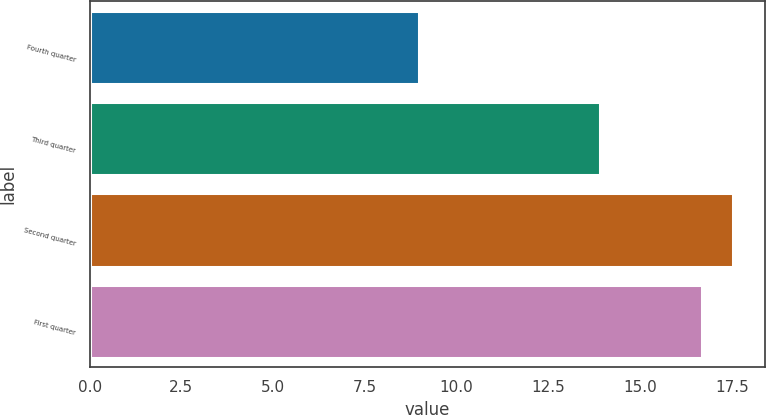<chart> <loc_0><loc_0><loc_500><loc_500><bar_chart><fcel>Fourth quarter<fcel>Third quarter<fcel>Second quarter<fcel>First quarter<nl><fcel>8.97<fcel>13.9<fcel>17.53<fcel>16.69<nl></chart> 